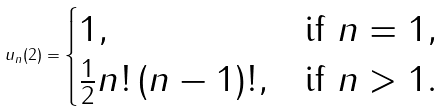Convert formula to latex. <formula><loc_0><loc_0><loc_500><loc_500>u _ { n } ( 2 ) = \begin{cases} 1 , & \text {if } n = 1 , \\ \frac { 1 } { 2 } n ! \, ( n - 1 ) ! , & \text {if } n > 1 . \end{cases}</formula> 